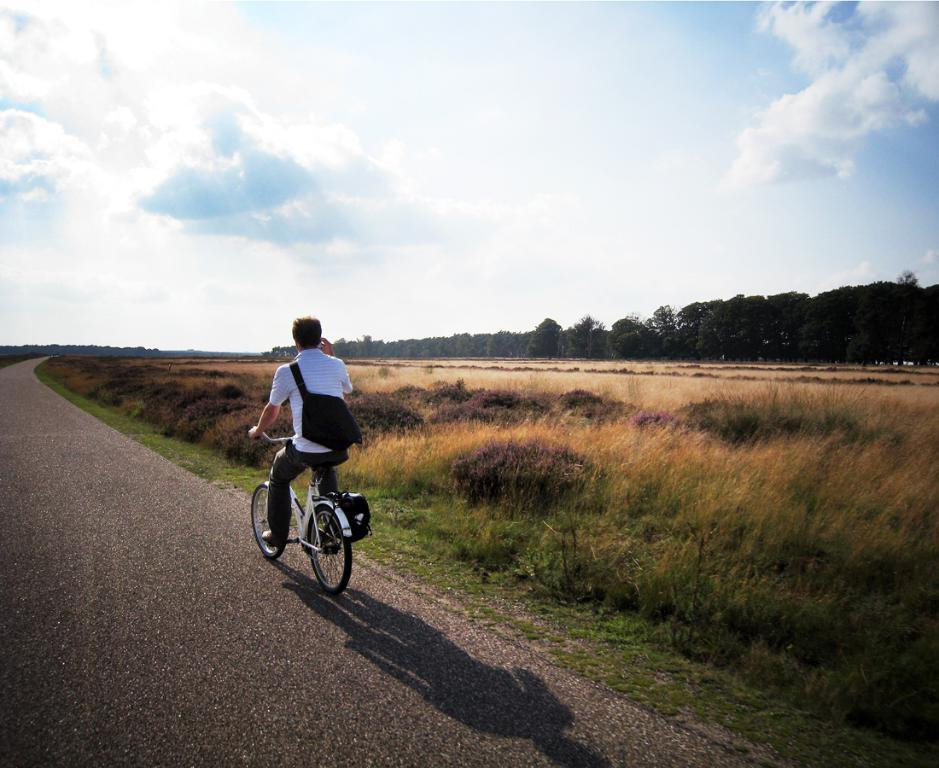What is the main subject of the image? The main subject of the image is a man. What is the man wearing in the image? The man is wearing a backpack. What is the man doing in the image? The man is riding a bicycle. Where is the bicycle located in the image? The bicycle is on a road. What can be seen in the background of the image? In the background of the image, there are plants, grass, trees, and the sky. What is the condition of the sky in the image? The sky is covered with clouds. What type of music can be heard coming from the robin in the image? There is no robin present in the image, and therefore no music can be heard coming from it. 